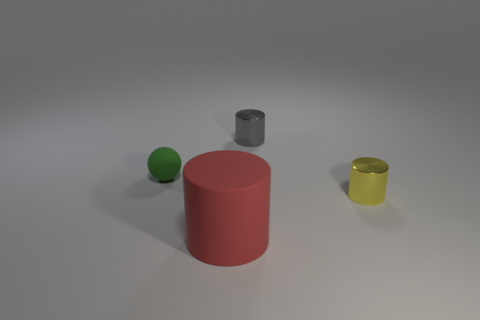Add 2 big matte cylinders. How many objects exist? 6 Subtract all spheres. How many objects are left? 3 Subtract 0 brown cylinders. How many objects are left? 4 Subtract all large cyan metal things. Subtract all yellow cylinders. How many objects are left? 3 Add 2 yellow things. How many yellow things are left? 3 Add 3 big brown matte balls. How many big brown matte balls exist? 3 